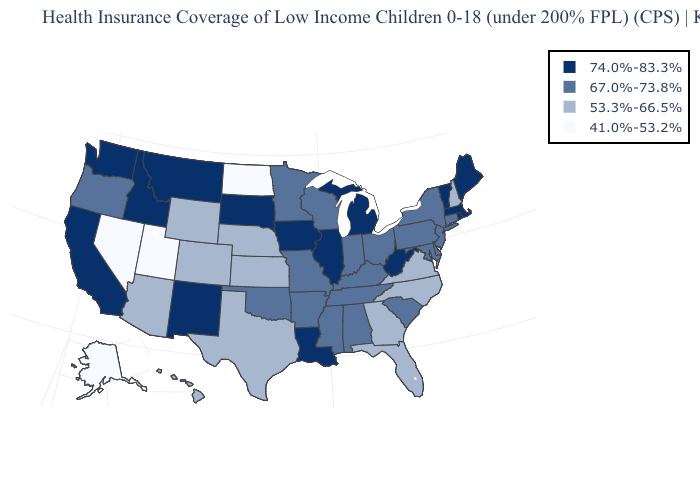Name the states that have a value in the range 41.0%-53.2%?
Concise answer only. Alaska, Nevada, North Dakota, Utah. Does the first symbol in the legend represent the smallest category?
Short answer required. No. Does Mississippi have the same value as Kentucky?
Answer briefly. Yes. Does Georgia have a lower value than Montana?
Write a very short answer. Yes. Which states have the lowest value in the South?
Concise answer only. Florida, Georgia, North Carolina, Texas, Virginia. What is the value of Florida?
Answer briefly. 53.3%-66.5%. Name the states that have a value in the range 53.3%-66.5%?
Answer briefly. Arizona, Colorado, Florida, Georgia, Hawaii, Kansas, Nebraska, New Hampshire, North Carolina, Texas, Virginia, Wyoming. Name the states that have a value in the range 67.0%-73.8%?
Be succinct. Alabama, Arkansas, Connecticut, Delaware, Indiana, Kentucky, Maryland, Minnesota, Mississippi, Missouri, New Jersey, New York, Ohio, Oklahoma, Oregon, Pennsylvania, South Carolina, Tennessee, Wisconsin. Name the states that have a value in the range 74.0%-83.3%?
Concise answer only. California, Idaho, Illinois, Iowa, Louisiana, Maine, Massachusetts, Michigan, Montana, New Mexico, Rhode Island, South Dakota, Vermont, Washington, West Virginia. Among the states that border Minnesota , which have the highest value?
Keep it brief. Iowa, South Dakota. What is the lowest value in states that border New Mexico?
Answer briefly. 41.0%-53.2%. What is the value of Hawaii?
Short answer required. 53.3%-66.5%. Does the first symbol in the legend represent the smallest category?
Short answer required. No. What is the lowest value in the West?
Concise answer only. 41.0%-53.2%. Name the states that have a value in the range 74.0%-83.3%?
Write a very short answer. California, Idaho, Illinois, Iowa, Louisiana, Maine, Massachusetts, Michigan, Montana, New Mexico, Rhode Island, South Dakota, Vermont, Washington, West Virginia. 